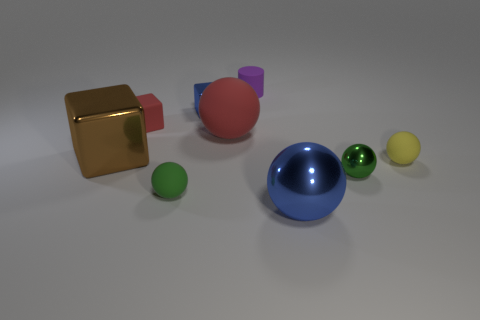Subtract all red balls. How many balls are left? 4 Subtract all blue spheres. How many spheres are left? 4 Subtract all purple balls. Subtract all brown cylinders. How many balls are left? 5 Subtract all cylinders. How many objects are left? 8 Add 9 blue balls. How many blue balls are left? 10 Add 9 small green shiny balls. How many small green shiny balls exist? 10 Subtract 0 green cylinders. How many objects are left? 9 Subtract all big blue metal balls. Subtract all tiny yellow matte things. How many objects are left? 7 